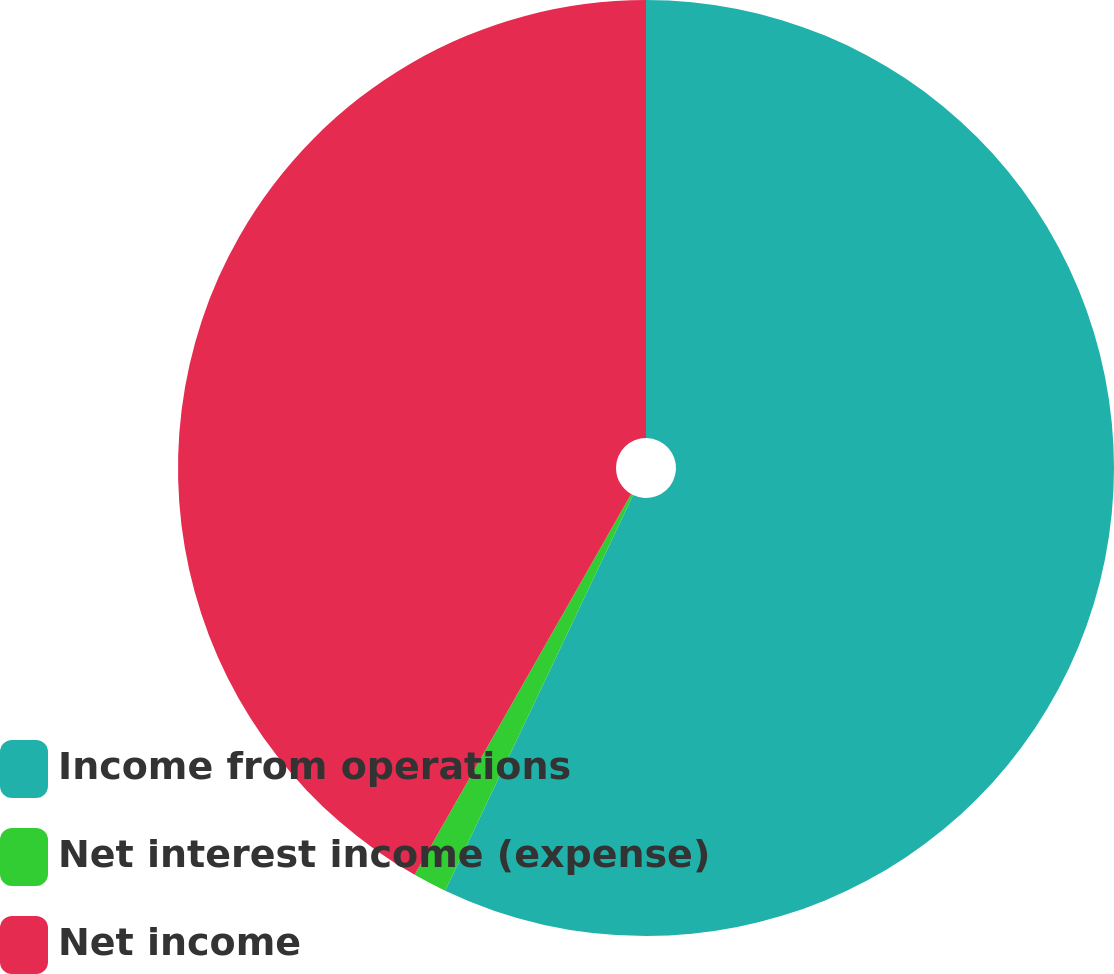<chart> <loc_0><loc_0><loc_500><loc_500><pie_chart><fcel>Income from operations<fcel>Net interest income (expense)<fcel>Net income<nl><fcel>57.06%<fcel>1.17%<fcel>41.77%<nl></chart> 